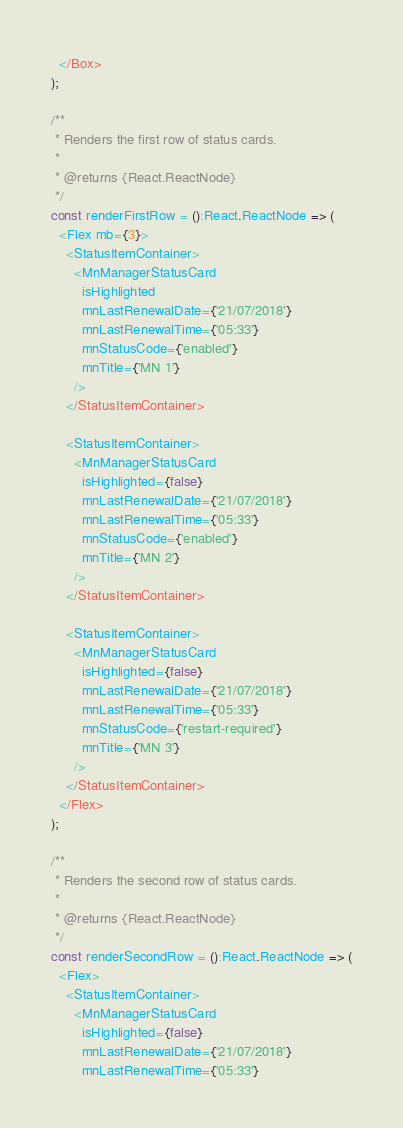<code> <loc_0><loc_0><loc_500><loc_500><_TypeScript_>  </Box>
);

/**
 * Renders the first row of status cards.
 *
 * @returns {React.ReactNode}
 */
const renderFirstRow = ():React.ReactNode => (
  <Flex mb={3}>
    <StatusItemContainer>
      <MnManagerStatusCard
        isHighlighted
        mnLastRenewalDate={'21/07/2018'}
        mnLastRenewalTime={'05:33'}
        mnStatusCode={'enabled'}
        mnTitle={'MN 1'}
      />
    </StatusItemContainer>

    <StatusItemContainer>
      <MnManagerStatusCard
        isHighlighted={false}
        mnLastRenewalDate={'21/07/2018'}
        mnLastRenewalTime={'05:33'}
        mnStatusCode={'enabled'}
        mnTitle={'MN 2'}
      />
    </StatusItemContainer>

    <StatusItemContainer>
      <MnManagerStatusCard
        isHighlighted={false}
        mnLastRenewalDate={'21/07/2018'}
        mnLastRenewalTime={'05:33'}
        mnStatusCode={'restart-required'}
        mnTitle={'MN 3'}
      />
    </StatusItemContainer>
  </Flex>
);

/**
 * Renders the second row of status cards.
 *
 * @returns {React.ReactNode}
 */
const renderSecondRow = ():React.ReactNode => (
  <Flex>
    <StatusItemContainer>
      <MnManagerStatusCard
        isHighlighted={false}
        mnLastRenewalDate={'21/07/2018'}
        mnLastRenewalTime={'05:33'}</code> 